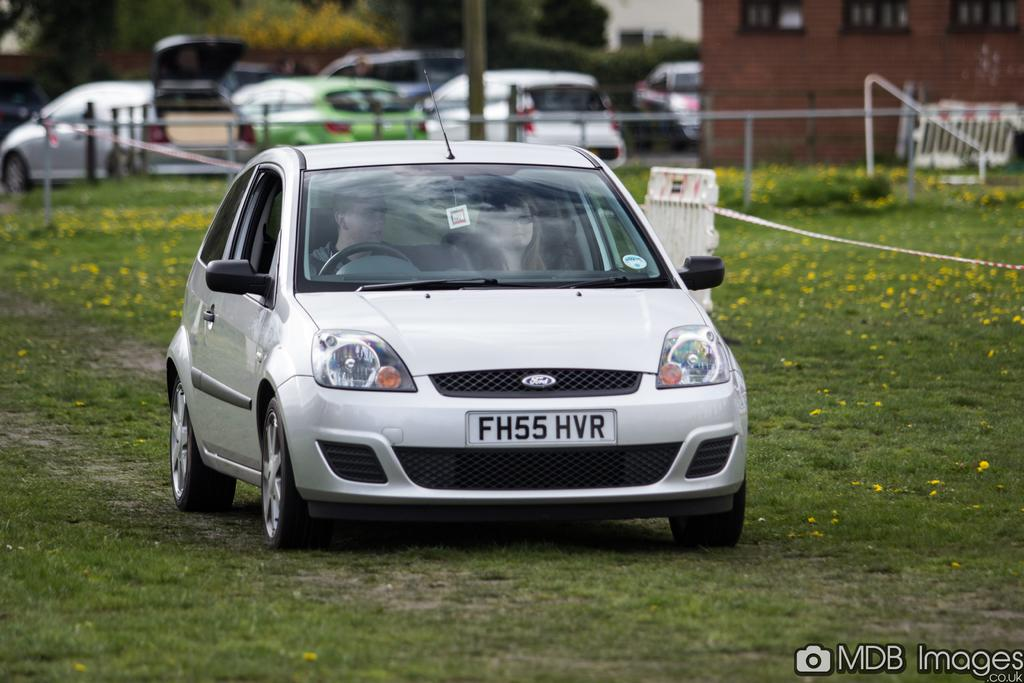How many people are inside the car in the image? There are two persons sitting inside the car. What can be seen in the background of the image? There are vehicles, a house, plants, and grass in the background of the image. Can you describe the setting of the image? The image shows a car with two people inside, and the background features a residential area with greenery. What type of wood can be seen in the heart of the image? There is no wood or heart present in the image; it features a car with two people inside and a background with various elements. 